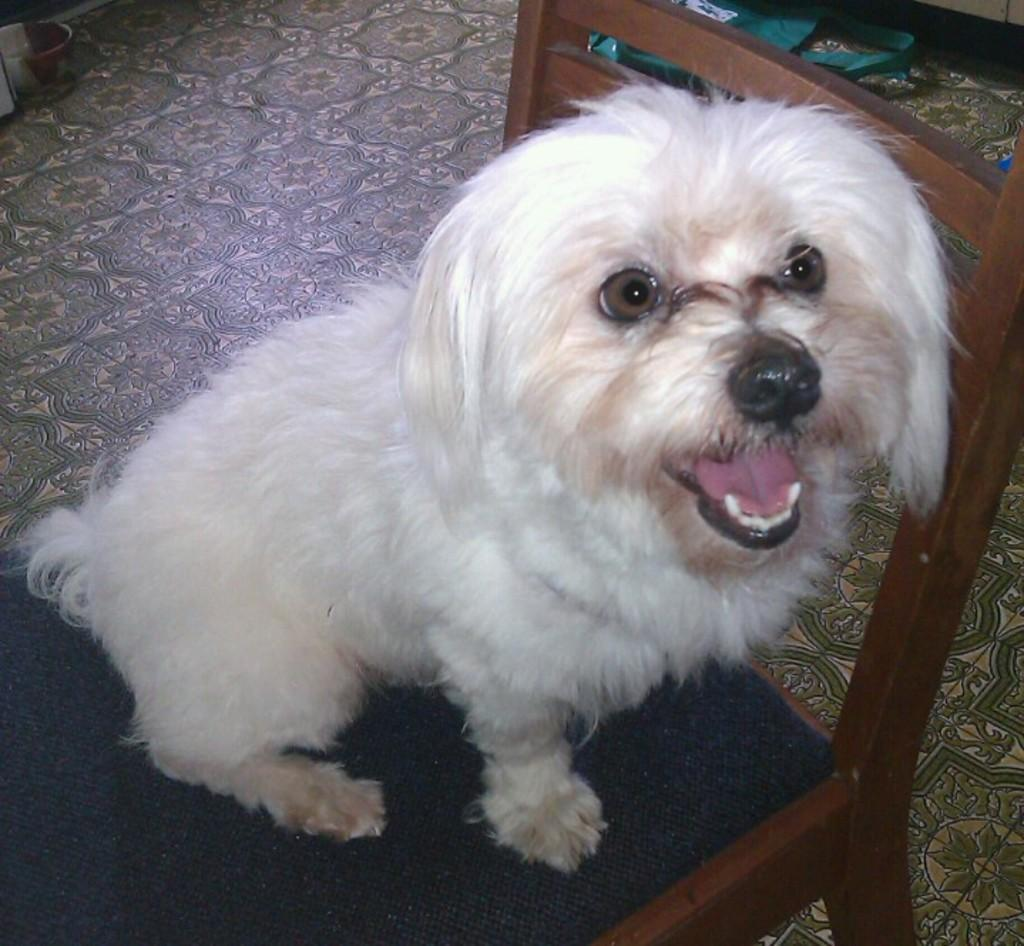What is the main subject in the foreground of the image? There is a dog in the foreground of the image. What is the dog doing in the image? The dog is on a chair. What can be seen in the background of the image? There are objects on the floor in the background of the image. Where was the image taken? The image was taken in a room. What type of shirt is the judge wearing in the image? There is no judge or shirt present in the image; it features a dog sitting on a chair in a room. 